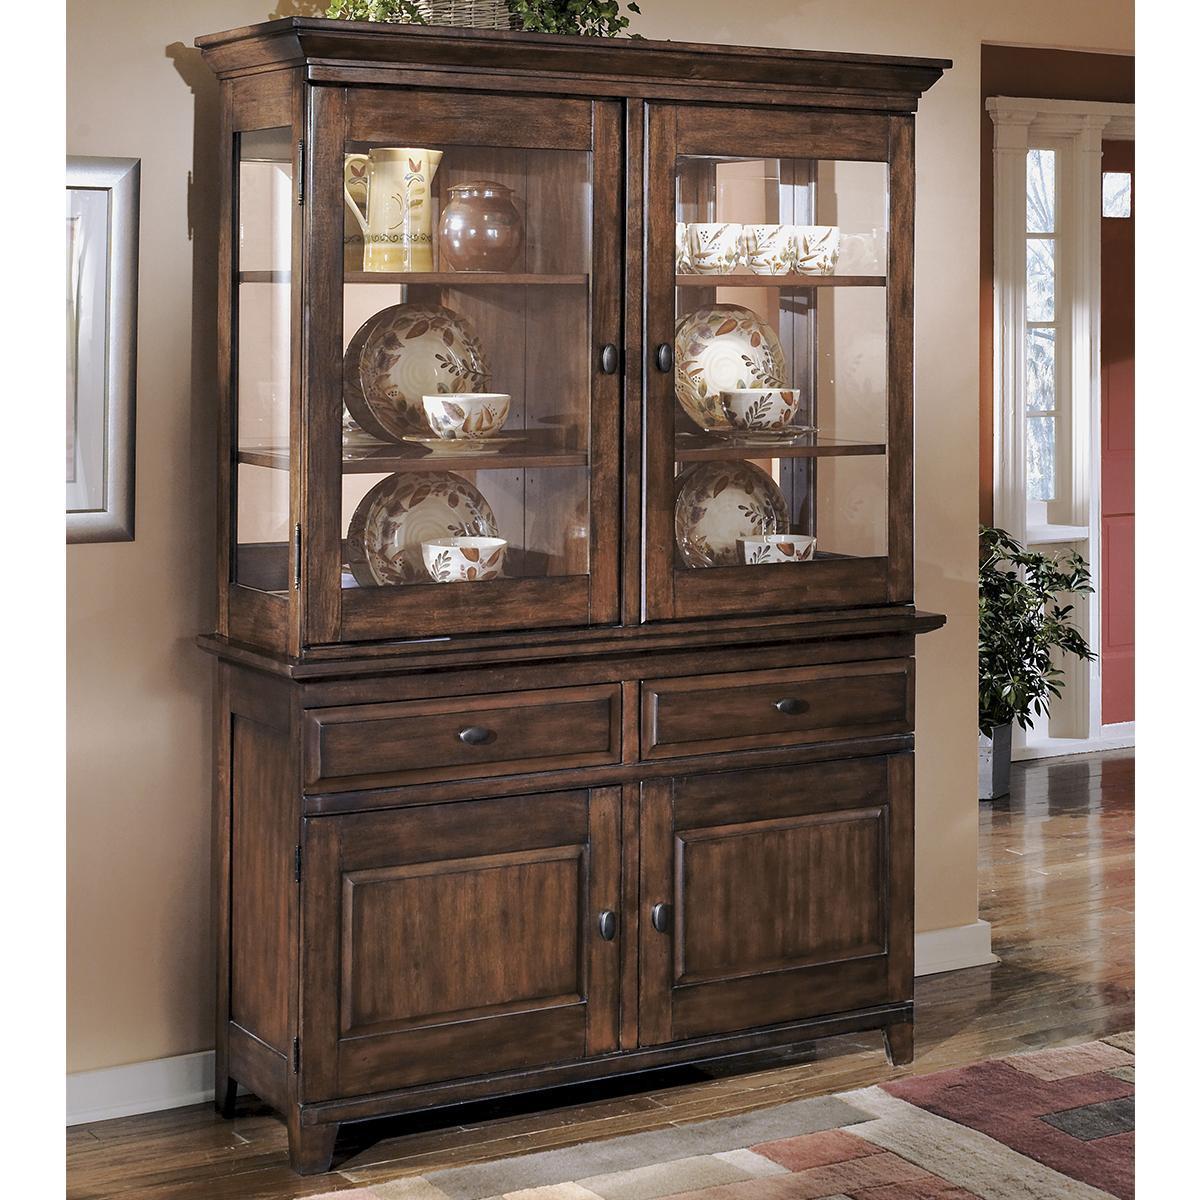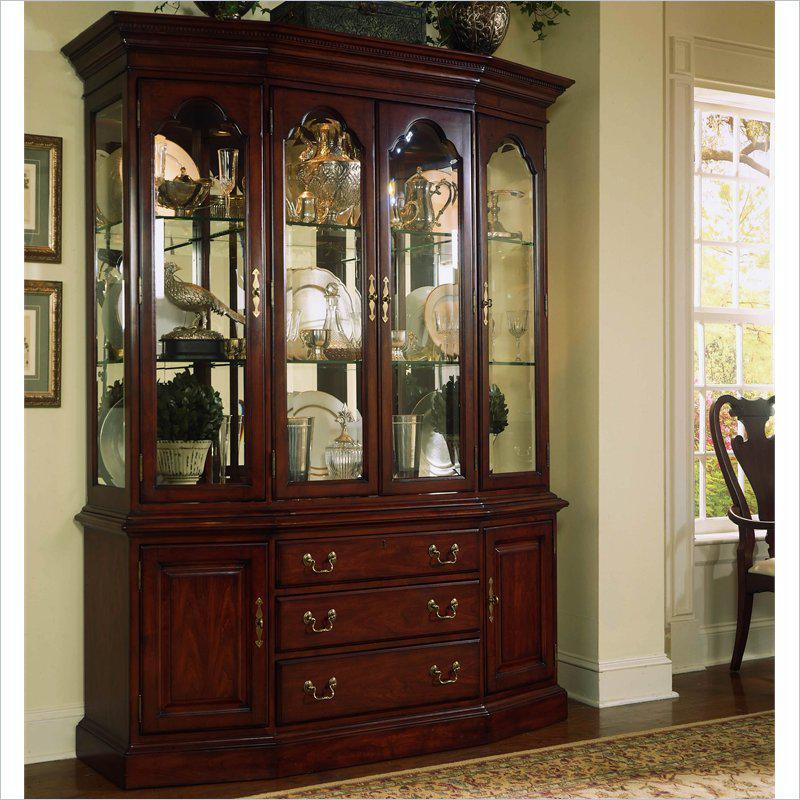The first image is the image on the left, the second image is the image on the right. Analyze the images presented: Is the assertion "All furniture on the images are brown" valid? Answer yes or no. Yes. 